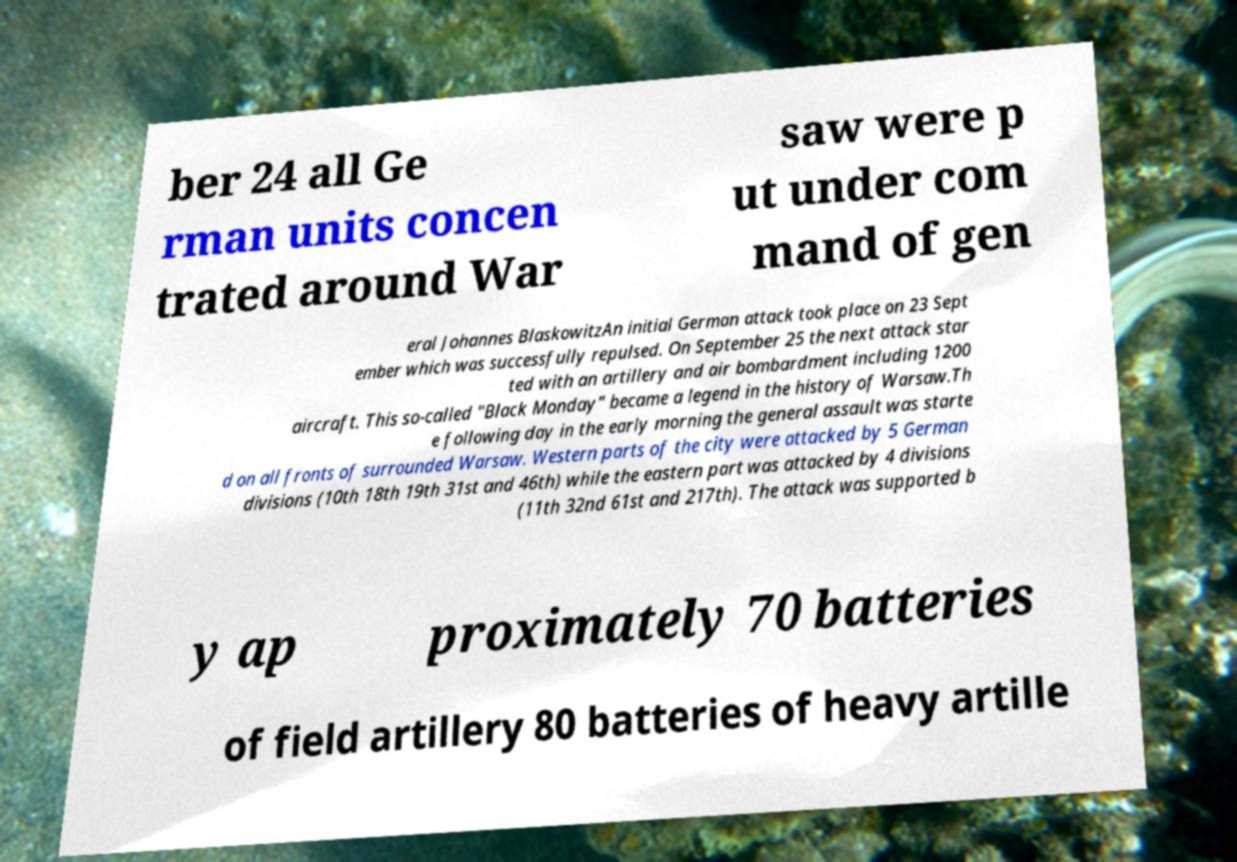Could you assist in decoding the text presented in this image and type it out clearly? ber 24 all Ge rman units concen trated around War saw were p ut under com mand of gen eral Johannes BlaskowitzAn initial German attack took place on 23 Sept ember which was successfully repulsed. On September 25 the next attack star ted with an artillery and air bombardment including 1200 aircraft. This so-called "Black Monday" became a legend in the history of Warsaw.Th e following day in the early morning the general assault was starte d on all fronts of surrounded Warsaw. Western parts of the city were attacked by 5 German divisions (10th 18th 19th 31st and 46th) while the eastern part was attacked by 4 divisions (11th 32nd 61st and 217th). The attack was supported b y ap proximately 70 batteries of field artillery 80 batteries of heavy artille 